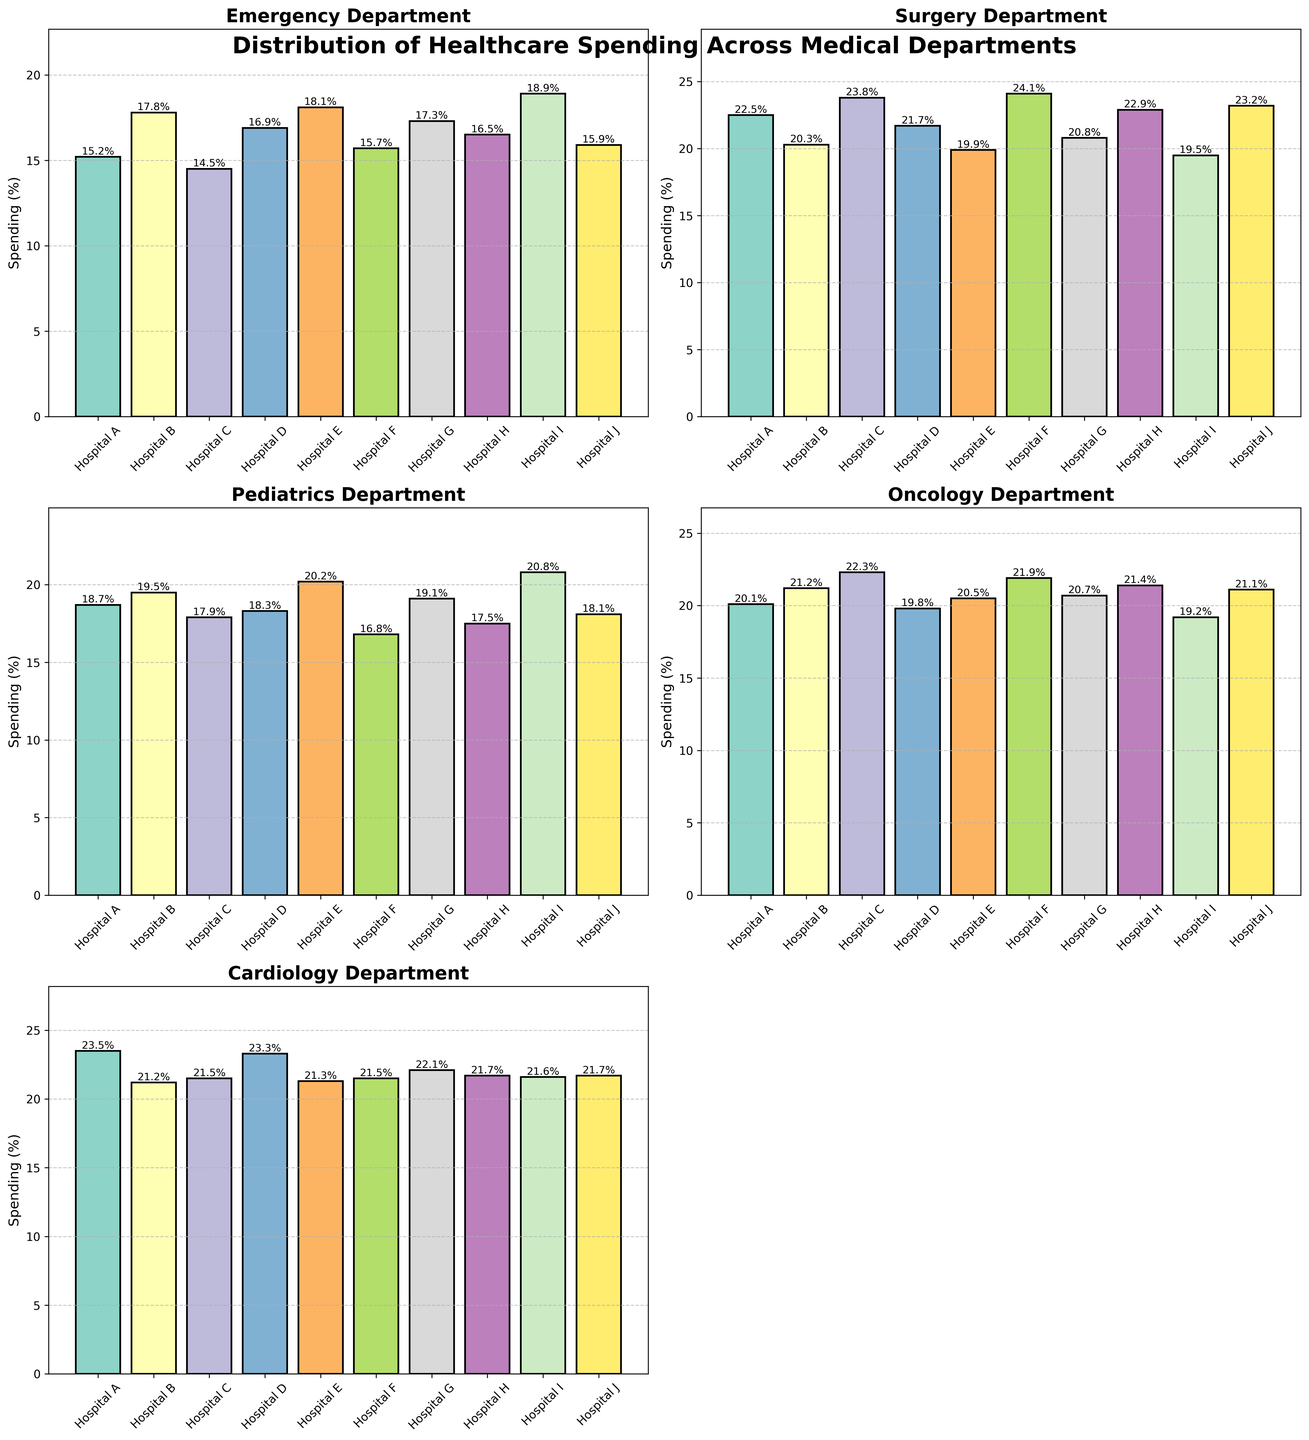Which hospital has the highest spending in the Emergency department? The bar representing Emergency spending for each hospital is compared, and the highest bar is identified. Hospital I has the highest bar for Emergency at 18.9%.
Answer: Hospital I Which department has the lowest spending at Hospital F? The spending values for Hospital F across all departments are compared. The lowest value is for Pediatrics at 16.8%.
Answer: Pediatrics What is the average spending in the Cardiology department across all hospitals? Sum the Cardiology spending values for all hospitals and divide by the number of hospitals: (23.5+21.2+21.5+23.3+21.3+21.5+22.1+21.7+21.6+21.7)/10 = 21.94.
Answer: 21.9% Which two hospitals have equal spending in the Cardiology department? The values for the Cardiology department are compared across hospitals to find matches. Hospital B and Hospital C both have 21.5% spending in Cardiology.
Answer: Hospital B and Hospital C Are there any departments where Hospital J has the highest spending compared to the other hospitals? For each department, compare Hospital J's spending with the other hospitals. Hospital J does not have the highest spending in any department.
Answer: No Which hospital has the greatest difference in spending between the Surgery and Pediatrics departments? Calculate the differences between Surgery and Pediatrics for each hospital and identify the maximum: Hospital F (24.1-16.8=7.3).
Answer: Hospital F What is the combined spending in the Oncology department for Hospitals G and H? Add the Oncology values for both hospitals: 20.7 + 21.4 = 42.1.
Answer: 42.1% Rank the hospitals in descending order of spending in the Surgery department. Sort the hospitals by their Surgery spending: Hospital F (24.1), Hospital C (23.8), Hospital J (23.2), Hospital A (22.5), Hospital H (22.9), Hospital D (21.7), Hospital G (20.8), Hospital B (20.3), Hospital E (19.9), Hospital I (19.5).
Answer: Hospital F, Hospital C, Hospital J, Hospital A, Hospital H, Hospital D, Hospital G, Hospital B, Hospital E, Hospital I What is the range of spending in the Pediatrics department across all hospitals? Subtract the minimum Pediatrics value from the maximum: 20.8 - 16.8 = 4.0.
Answer: 4.0% By how much does Hospital E's spending in Pediatrics exceed its spending in Emergency? Subtract Emergency from Pediatrics for Hospital E: 20.2 - 18.1 = 2.1.
Answer: 2.1% 